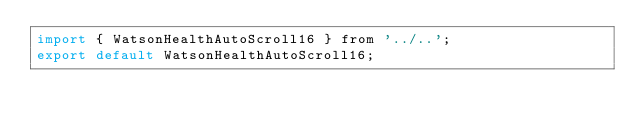<code> <loc_0><loc_0><loc_500><loc_500><_JavaScript_>import { WatsonHealthAutoScroll16 } from '../..';
export default WatsonHealthAutoScroll16;
</code> 